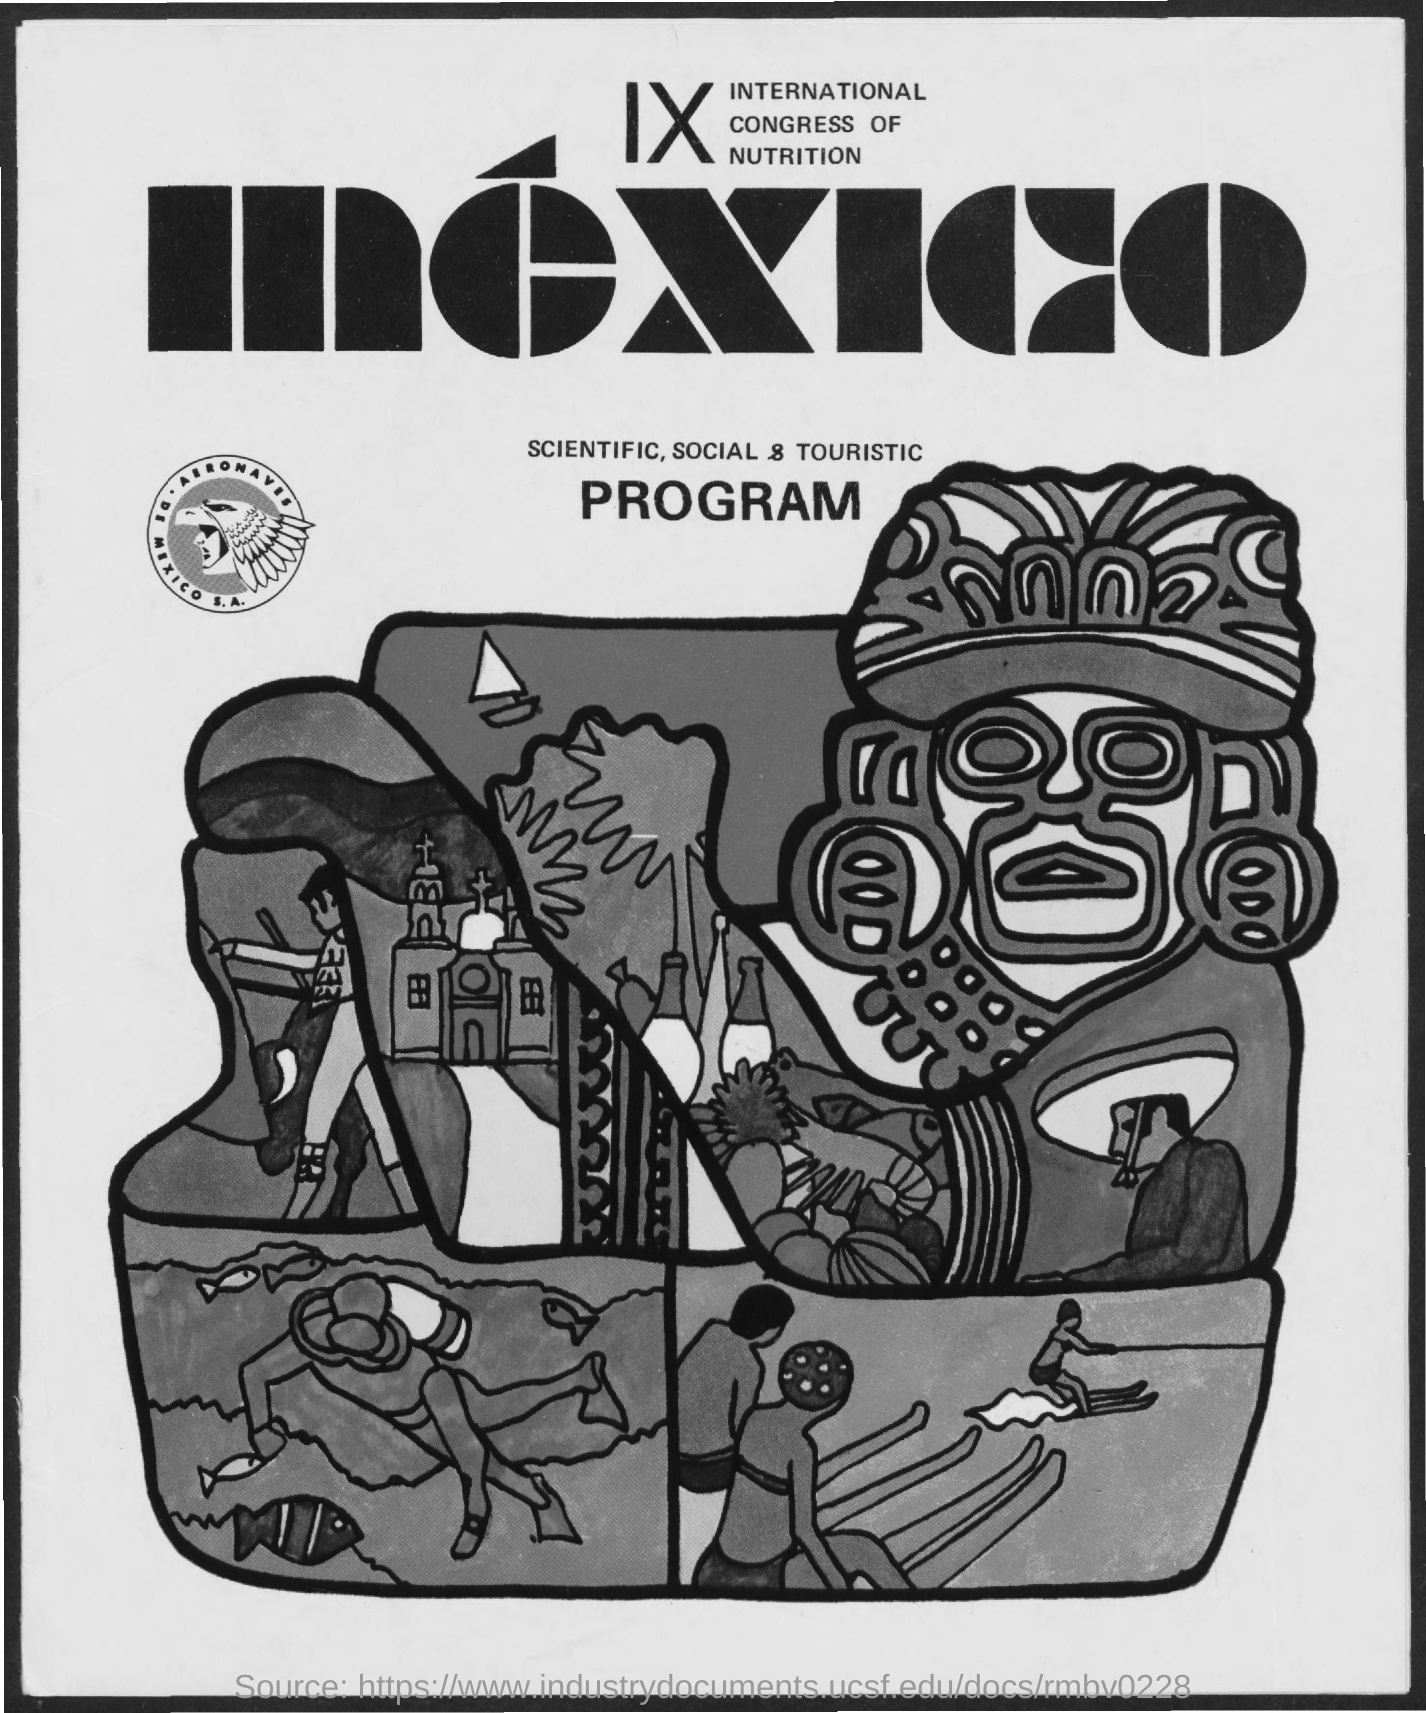Where will the 9th international congress of nutrition is planned ?
Ensure brevity in your answer.  Mexico. 